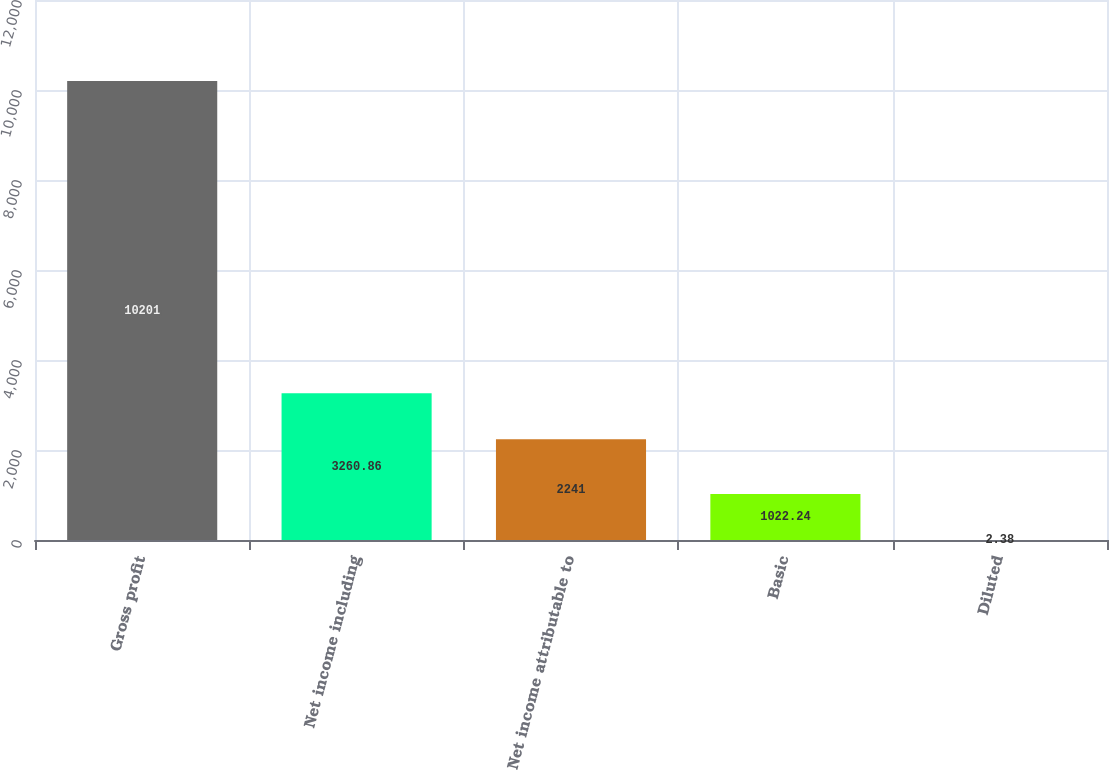<chart> <loc_0><loc_0><loc_500><loc_500><bar_chart><fcel>Gross profit<fcel>Net income including<fcel>Net income attributable to<fcel>Basic<fcel>Diluted<nl><fcel>10201<fcel>3260.86<fcel>2241<fcel>1022.24<fcel>2.38<nl></chart> 